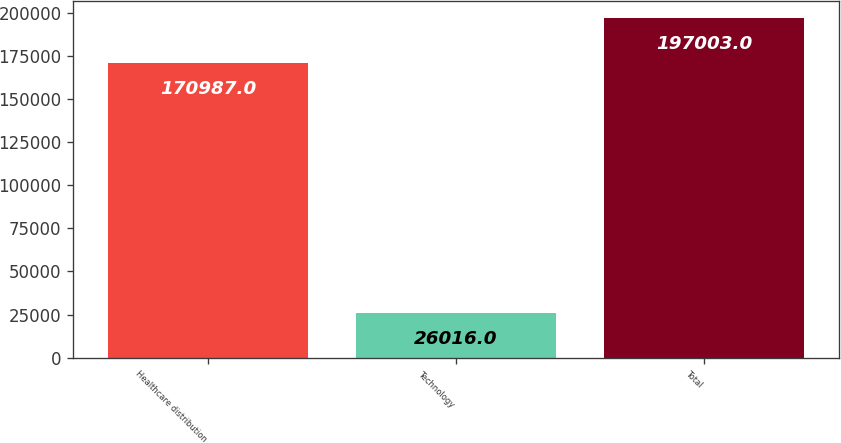Convert chart. <chart><loc_0><loc_0><loc_500><loc_500><bar_chart><fcel>Healthcare distribution<fcel>Technology<fcel>Total<nl><fcel>170987<fcel>26016<fcel>197003<nl></chart> 